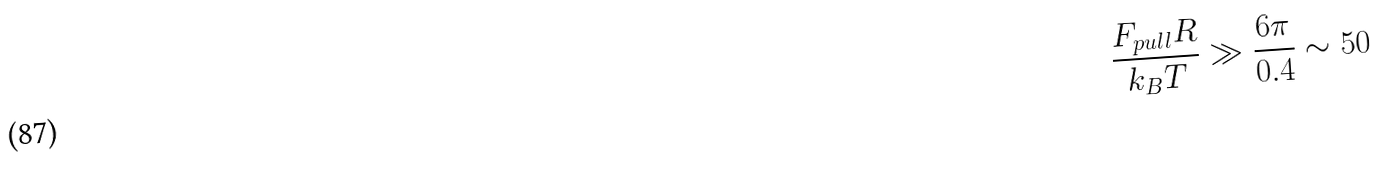<formula> <loc_0><loc_0><loc_500><loc_500>\frac { F _ { p u l l } R } { k _ { B } T } \gg \frac { 6 \pi } { 0 . 4 } \sim 5 0</formula> 